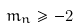Convert formula to latex. <formula><loc_0><loc_0><loc_500><loc_500>m _ { n } \geq - 2</formula> 